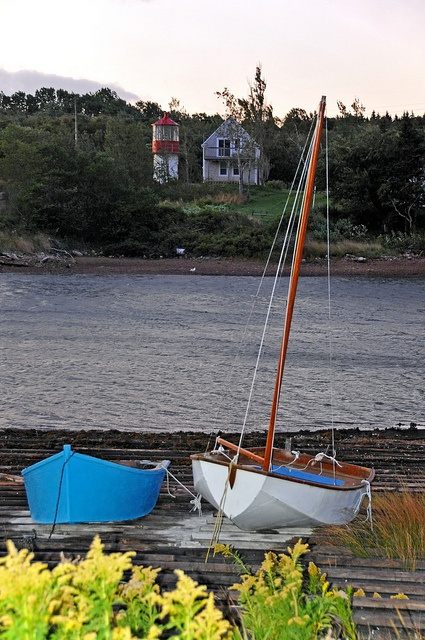Describe the objects in this image and their specific colors. I can see boat in white, darkgray, gray, black, and lightgray tones and boat in white, teal, and black tones in this image. 